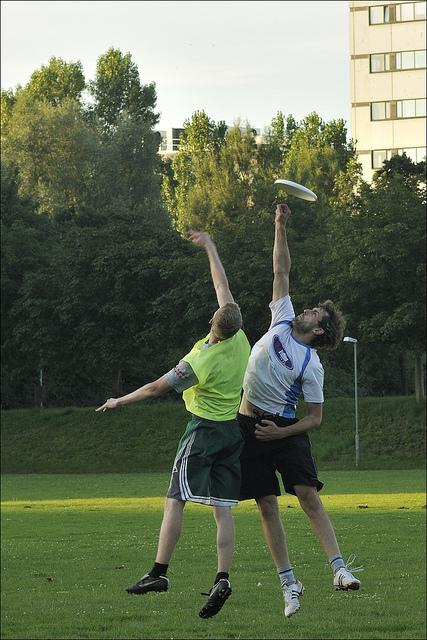What allows this toy to fly? Please explain your reasoning. lift. Frisbees have to have air. 